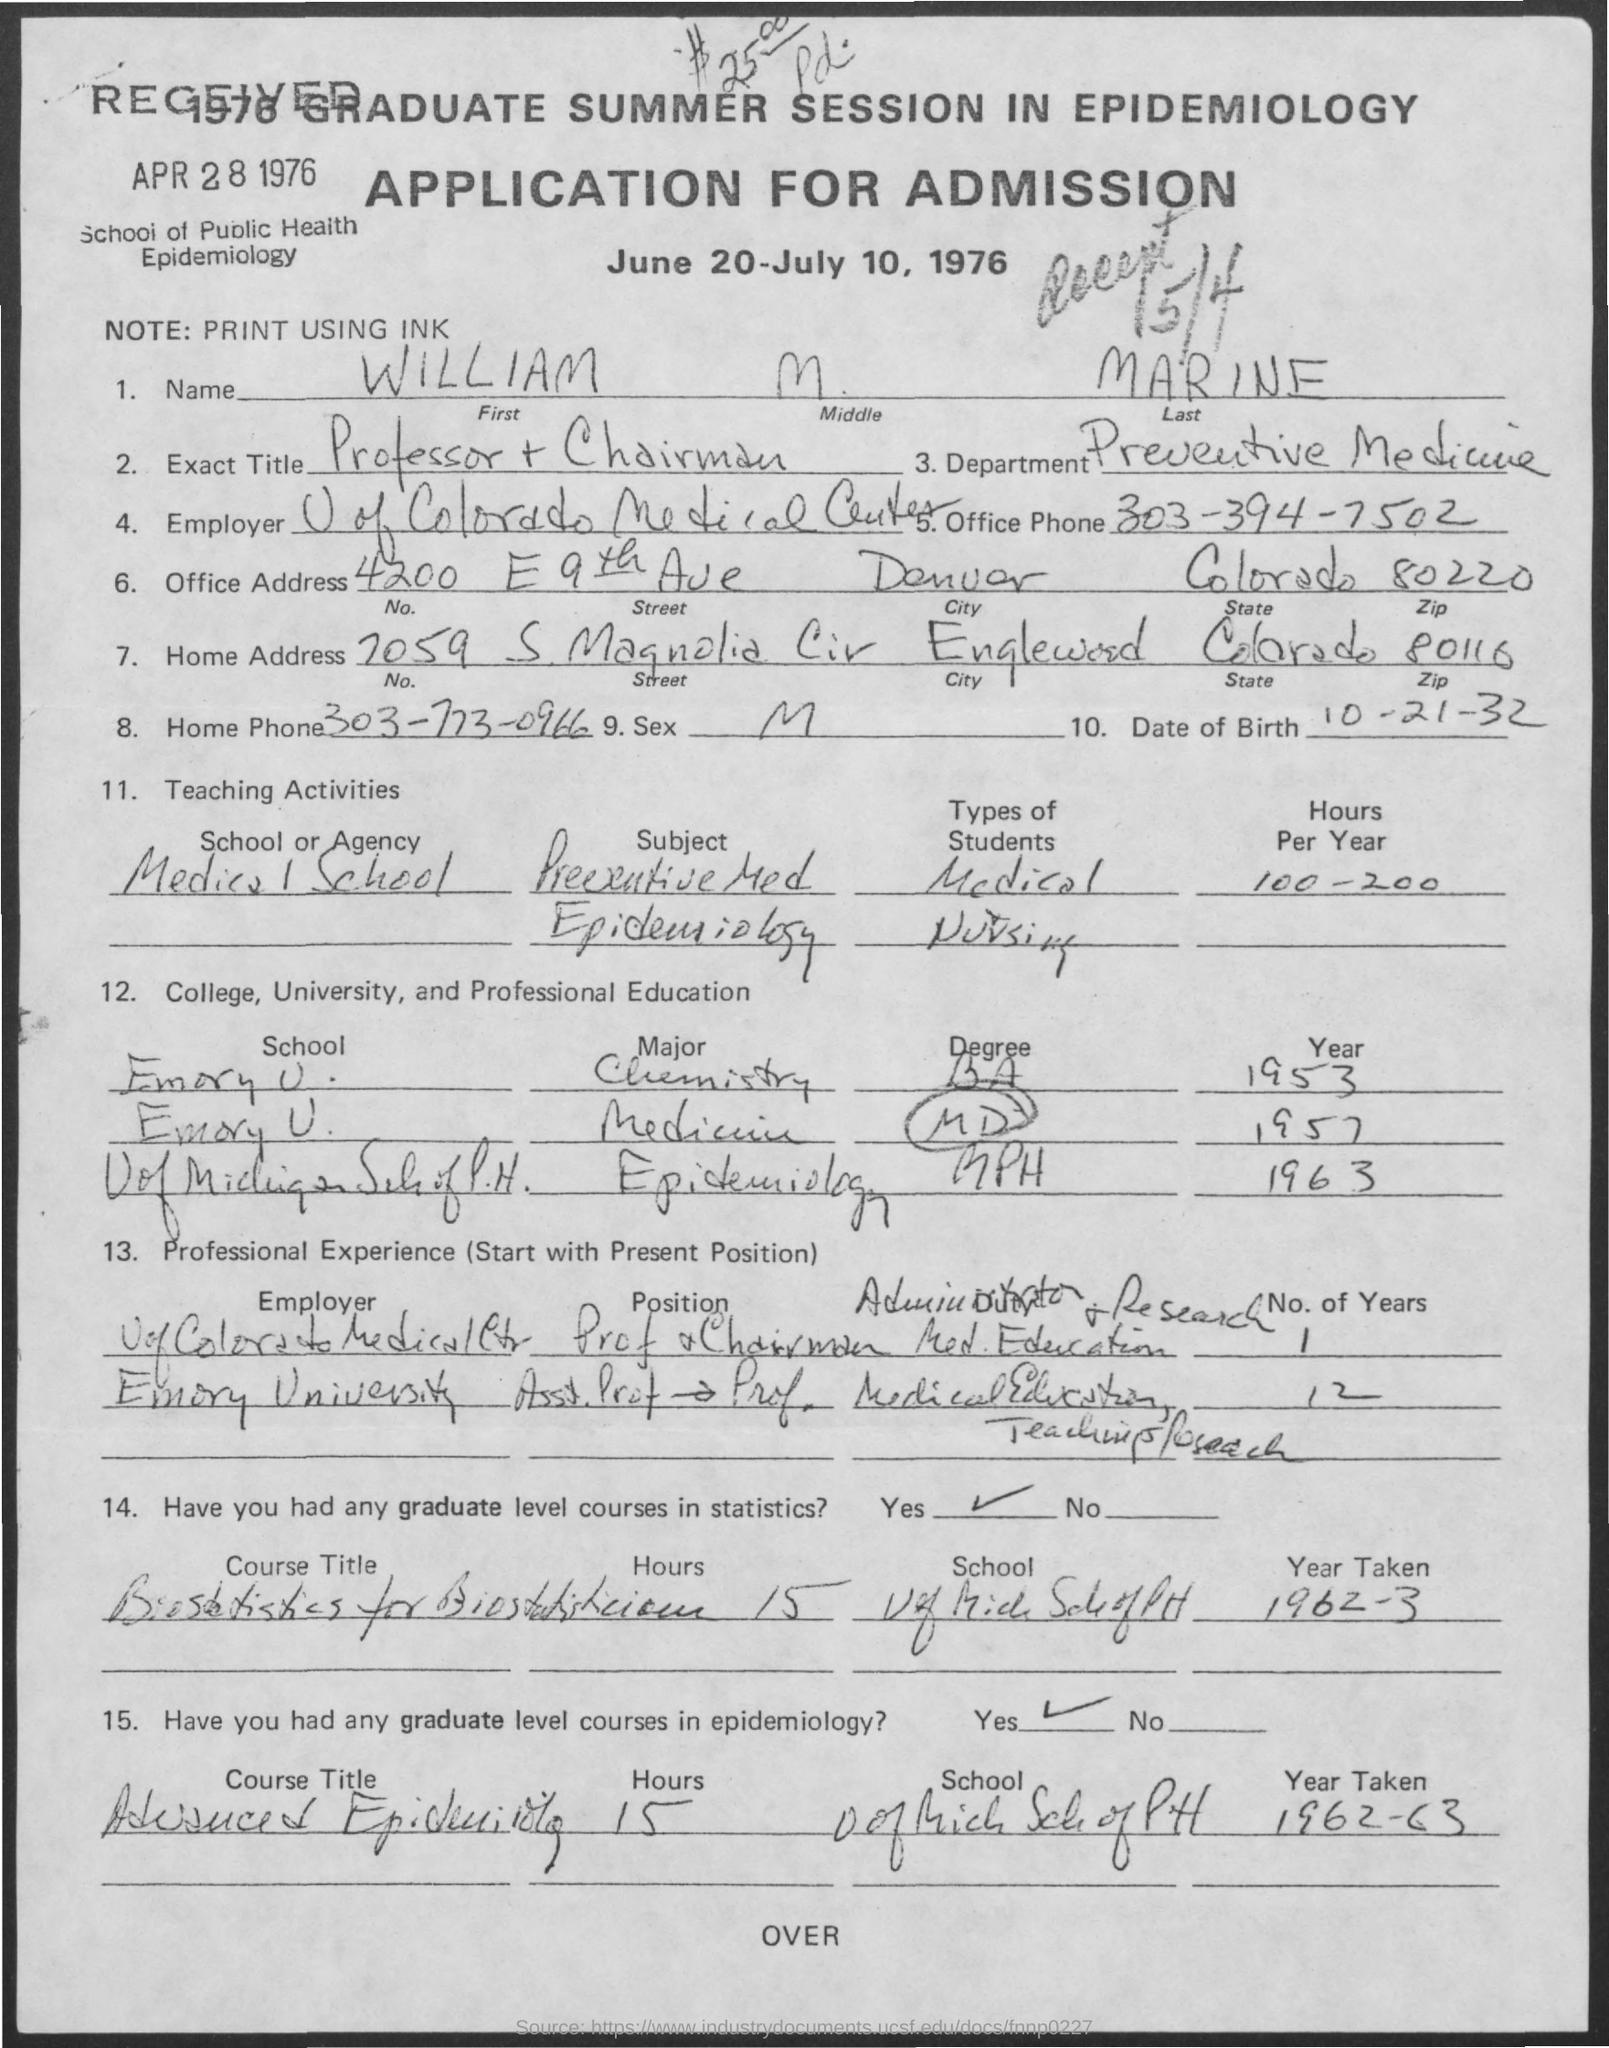Specify some key components in this picture. The Note Field contains the printed text 'PRINT USING INK.' using ink. The home phone number is 303-773-0966. The office phone number is 303-394-7502. The home address number is 7059. 